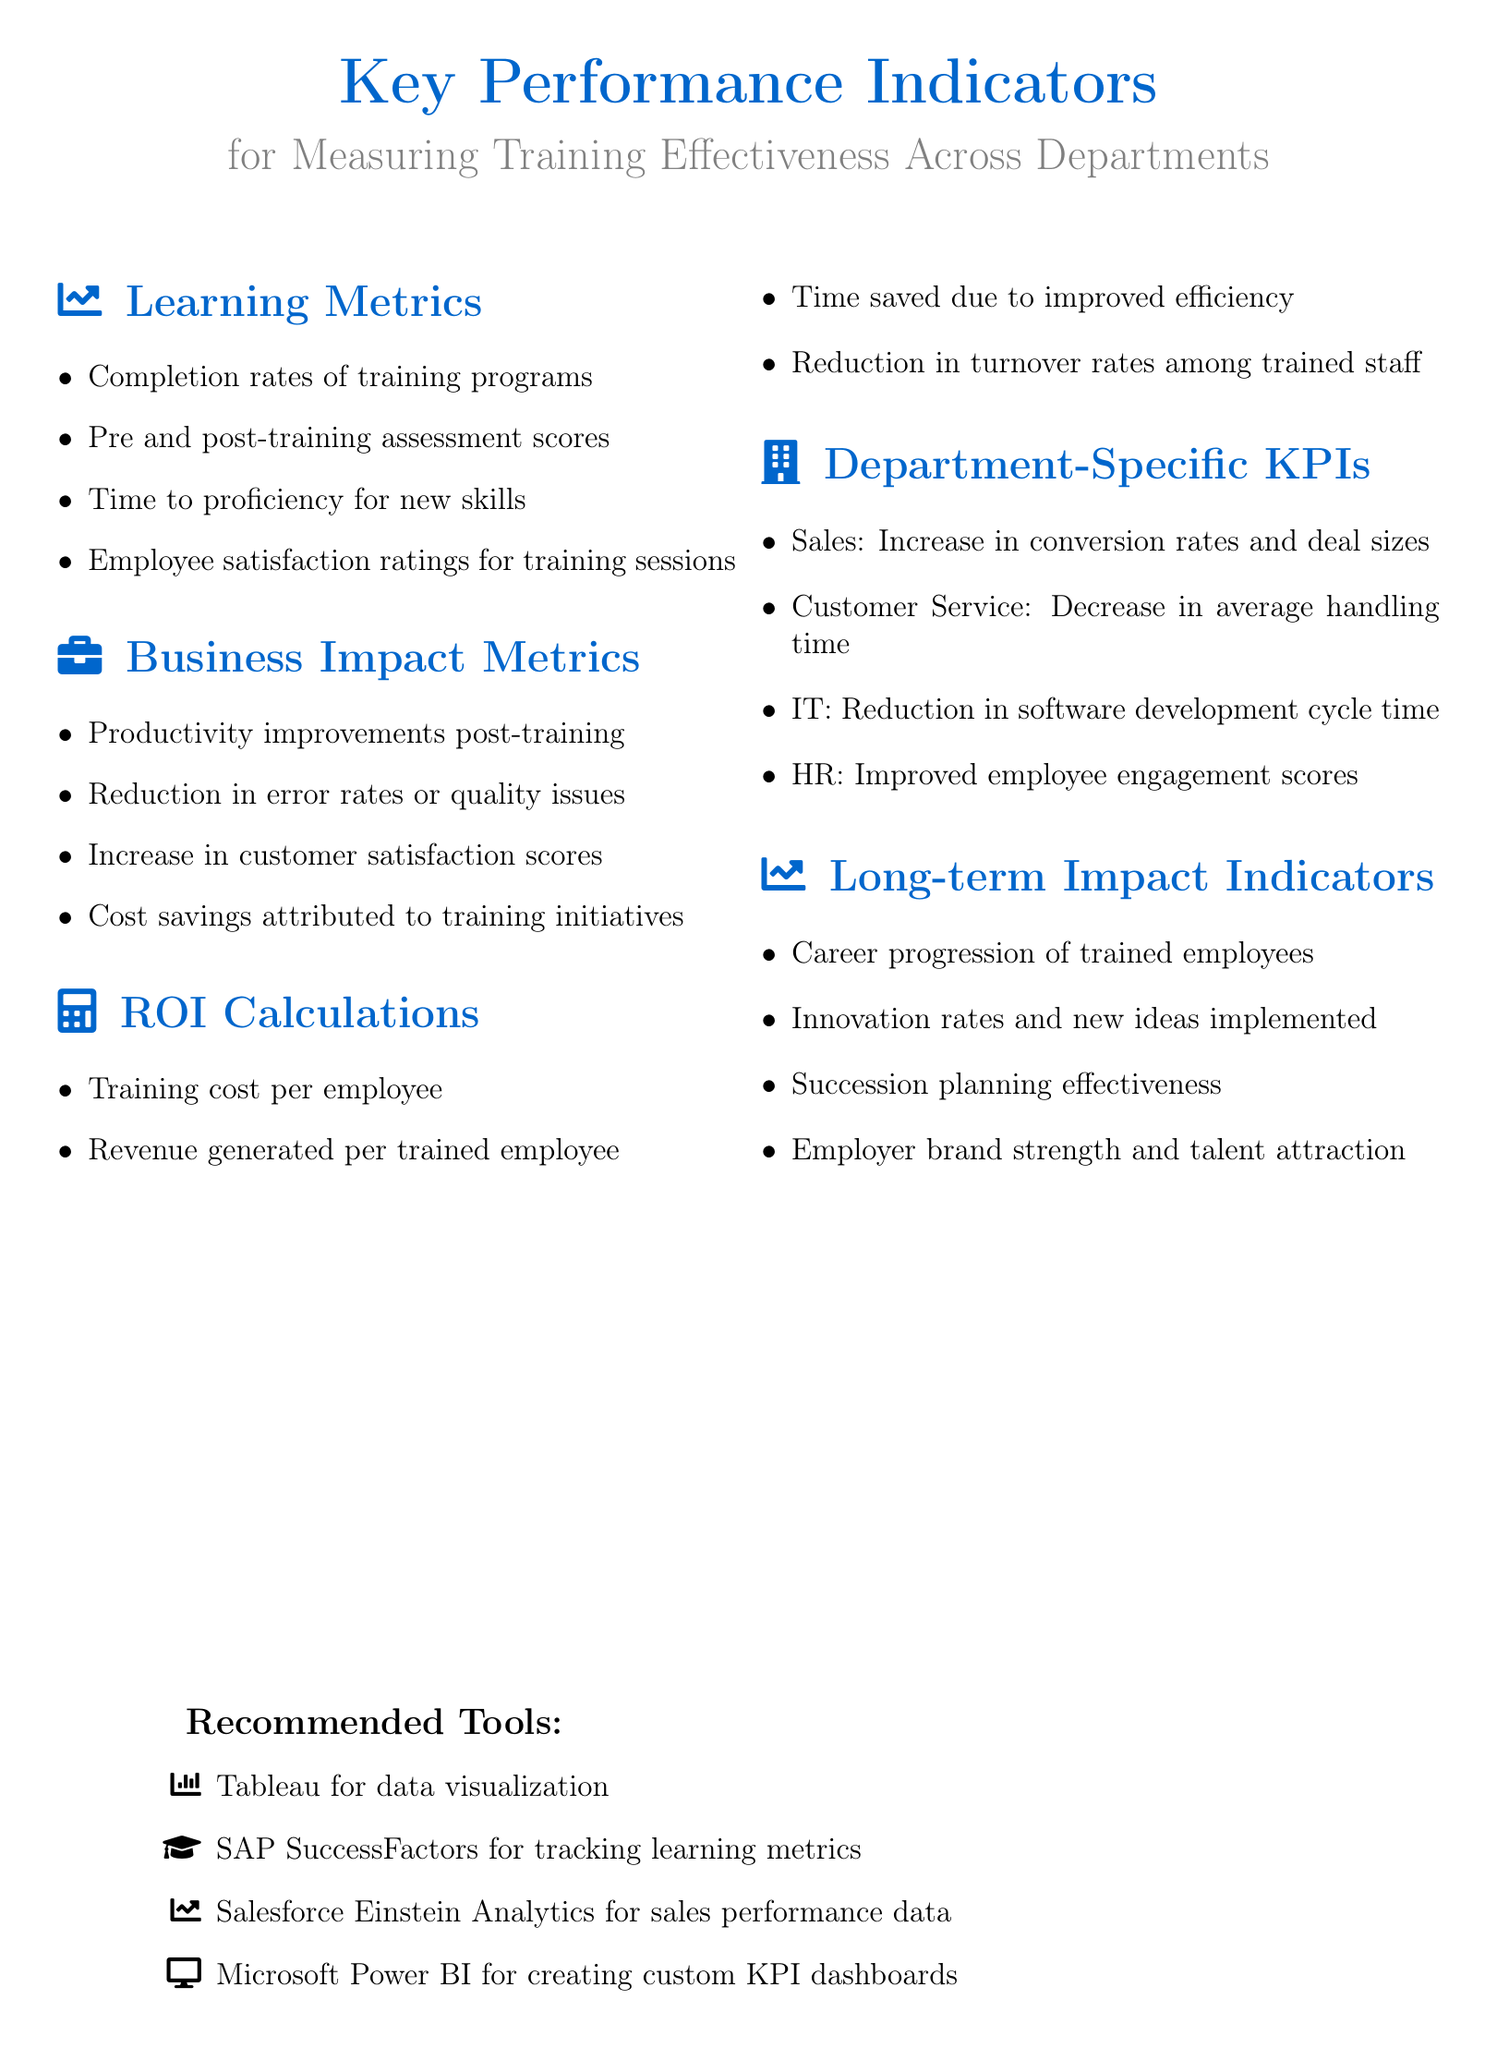What are the learning metrics? The learning metrics are listed under the "Learning Metrics" section, which includes key measurements for training effectiveness.
Answer: Completion rates, Pre and post-training assessment scores, Time to proficiency for new skills, Employee satisfaction ratings for training sessions What is one department-specific KPI for Sales? The document details specific KPIs for different departments, particularly Sales.
Answer: Increase in conversion rates and deal sizes What tool is recommended for tracking learning metrics? The document recommends specific tools for various tasks, including learning metric tracking.
Answer: SAP SuccessFactors What are the long-term impact indicators mentioned? The document outlines indicators that reflect the long-term benefits of training, found in the "Long-term Impact Indicators" section.
Answer: Career progression of trained employees, Innovation rates and new ideas implemented, Succession planning effectiveness, Employer brand strength and talent attraction How are ROI calculations measured? This question examines how to evaluate return on investment from training initiatives, as defined in the ROI Calculations section.
Answer: Training cost per employee, Revenue generated per trained employee, Time saved due to improved efficiency, Reduction in turnover rates among trained staff 